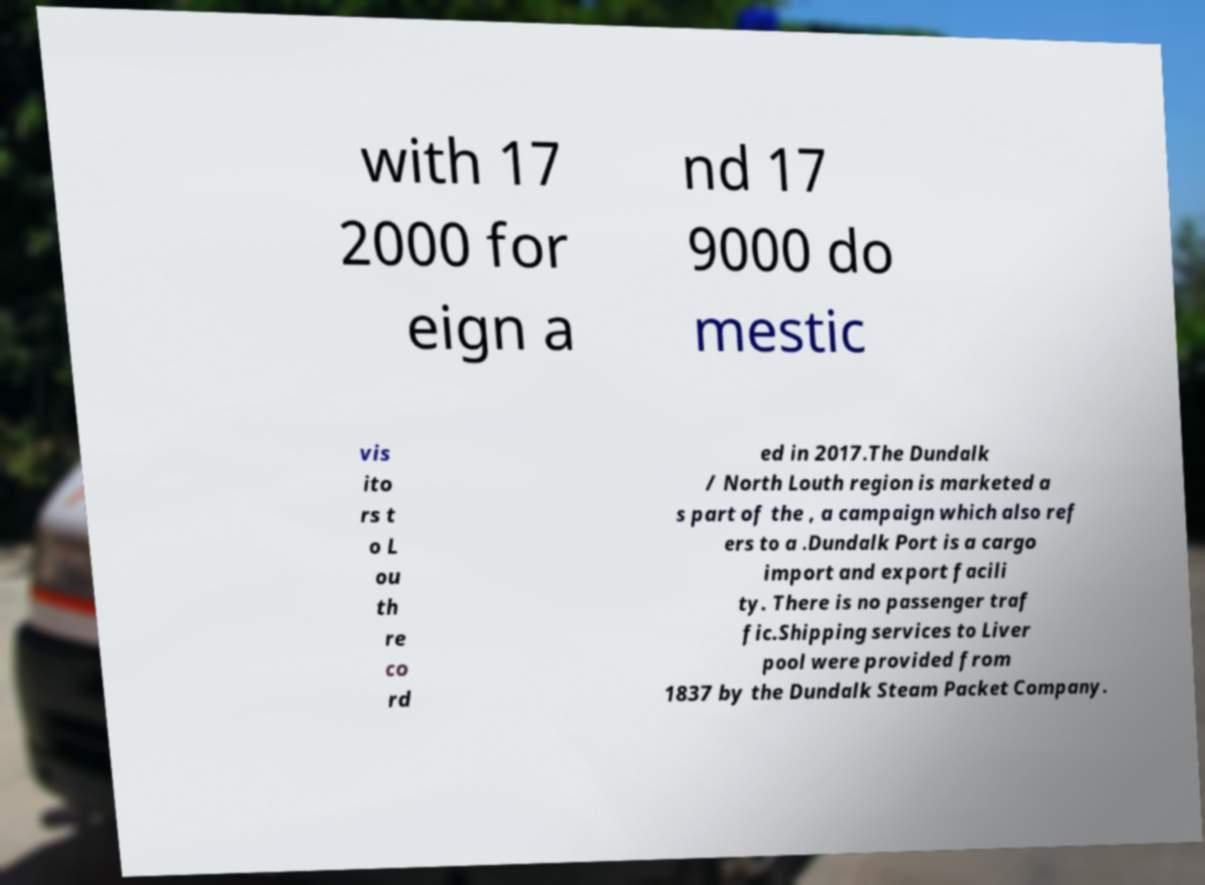For documentation purposes, I need the text within this image transcribed. Could you provide that? with 17 2000 for eign a nd 17 9000 do mestic vis ito rs t o L ou th re co rd ed in 2017.The Dundalk / North Louth region is marketed a s part of the , a campaign which also ref ers to a .Dundalk Port is a cargo import and export facili ty. There is no passenger traf fic.Shipping services to Liver pool were provided from 1837 by the Dundalk Steam Packet Company. 